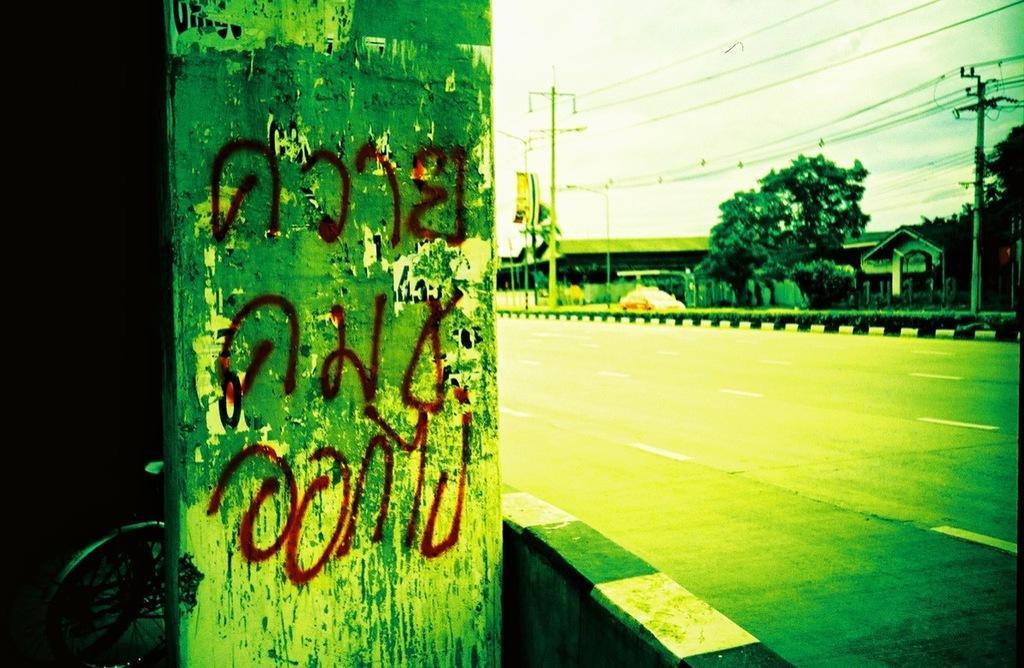Could you give a brief overview of what you see in this image? This is an edited picture. In the foreground there is a pole and there is a bicycle behind the pole. On the right side of the image there are buildings, trees and poles and there is a vehicle on the road and there are wires on the poles. At the top there is sky. At the bottom there is a road. 